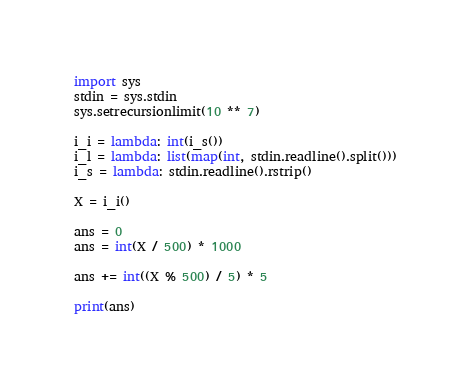<code> <loc_0><loc_0><loc_500><loc_500><_Python_>import sys
stdin = sys.stdin
sys.setrecursionlimit(10 ** 7)

i_i = lambda: int(i_s())
i_l = lambda: list(map(int, stdin.readline().split()))
i_s = lambda: stdin.readline().rstrip()

X = i_i()

ans = 0
ans = int(X / 500) * 1000

ans += int((X % 500) / 5) * 5

print(ans)</code> 